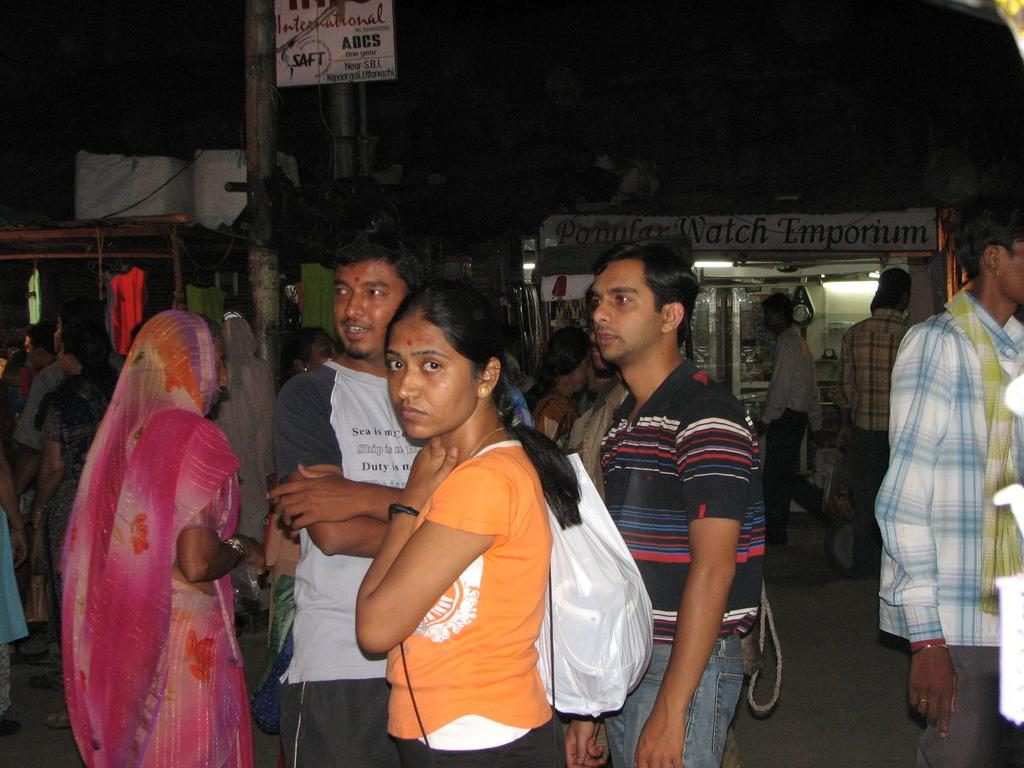How many people are in the image? There are people in the image, but the exact number is not specified. What is one of the people holding? One of the people is holding a cover. What type of establishments can be seen in the image? There are shops in the image. What object is present in the image that is typically used for support or display? There is a pole in the image. Can you see any horses in the image? No, there are no horses present in the image. Is there a tent visible in the image? No, there is no tent visible in the image. 